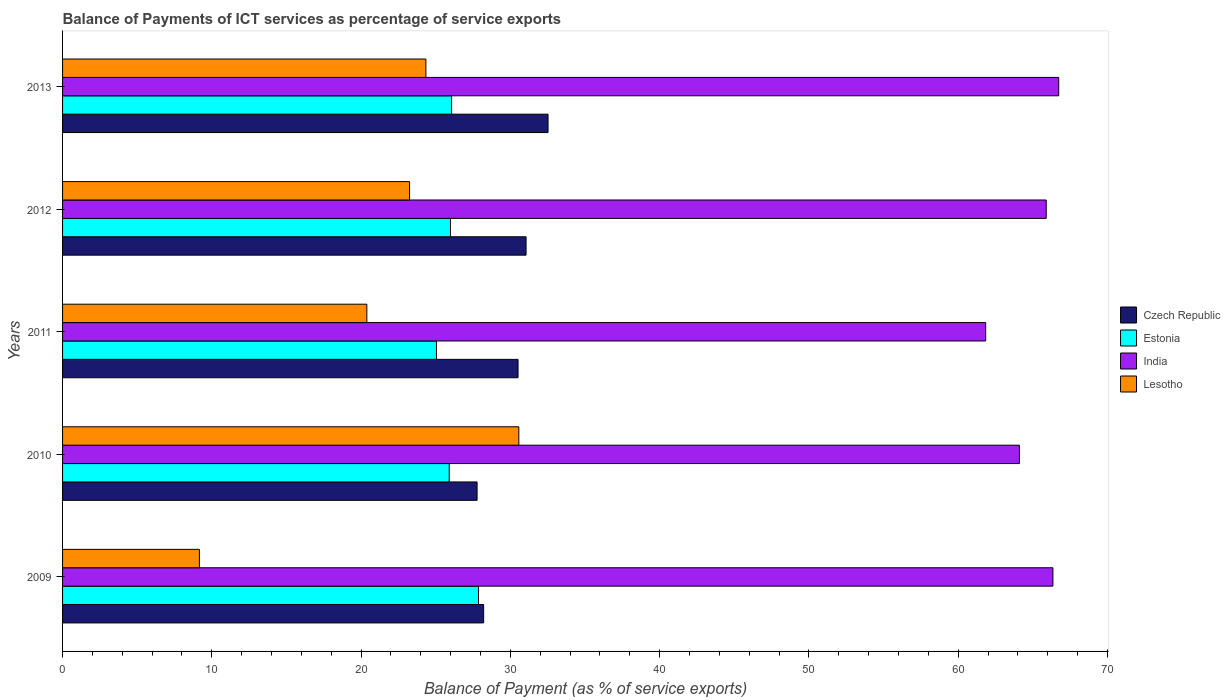How many different coloured bars are there?
Provide a short and direct response. 4. What is the label of the 1st group of bars from the top?
Offer a very short reply. 2013. In how many cases, is the number of bars for a given year not equal to the number of legend labels?
Offer a very short reply. 0. What is the balance of payments of ICT services in India in 2009?
Make the answer very short. 66.34. Across all years, what is the maximum balance of payments of ICT services in India?
Offer a very short reply. 66.73. Across all years, what is the minimum balance of payments of ICT services in India?
Keep it short and to the point. 61.84. In which year was the balance of payments of ICT services in Estonia minimum?
Ensure brevity in your answer.  2011. What is the total balance of payments of ICT services in Lesotho in the graph?
Provide a succinct answer. 107.7. What is the difference between the balance of payments of ICT services in India in 2010 and that in 2011?
Make the answer very short. 2.26. What is the difference between the balance of payments of ICT services in Estonia in 2009 and the balance of payments of ICT services in Lesotho in 2013?
Provide a succinct answer. 3.52. What is the average balance of payments of ICT services in India per year?
Keep it short and to the point. 64.98. In the year 2011, what is the difference between the balance of payments of ICT services in India and balance of payments of ICT services in Czech Republic?
Provide a succinct answer. 31.33. In how many years, is the balance of payments of ICT services in Lesotho greater than 26 %?
Provide a succinct answer. 1. What is the ratio of the balance of payments of ICT services in Lesotho in 2010 to that in 2012?
Your response must be concise. 1.31. Is the balance of payments of ICT services in India in 2011 less than that in 2012?
Keep it short and to the point. Yes. Is the difference between the balance of payments of ICT services in India in 2011 and 2012 greater than the difference between the balance of payments of ICT services in Czech Republic in 2011 and 2012?
Keep it short and to the point. No. What is the difference between the highest and the second highest balance of payments of ICT services in Estonia?
Ensure brevity in your answer.  1.8. What is the difference between the highest and the lowest balance of payments of ICT services in Lesotho?
Make the answer very short. 21.4. In how many years, is the balance of payments of ICT services in Estonia greater than the average balance of payments of ICT services in Estonia taken over all years?
Provide a succinct answer. 1. What does the 3rd bar from the top in 2013 represents?
Provide a succinct answer. Estonia. What does the 4th bar from the bottom in 2010 represents?
Provide a succinct answer. Lesotho. Is it the case that in every year, the sum of the balance of payments of ICT services in Czech Republic and balance of payments of ICT services in Lesotho is greater than the balance of payments of ICT services in Estonia?
Provide a short and direct response. Yes. How many bars are there?
Offer a terse response. 20. How many years are there in the graph?
Your answer should be very brief. 5. Are the values on the major ticks of X-axis written in scientific E-notation?
Your answer should be compact. No. Does the graph contain any zero values?
Ensure brevity in your answer.  No. Does the graph contain grids?
Offer a terse response. No. Where does the legend appear in the graph?
Provide a short and direct response. Center right. How many legend labels are there?
Keep it short and to the point. 4. What is the title of the graph?
Offer a very short reply. Balance of Payments of ICT services as percentage of service exports. Does "East Asia (all income levels)" appear as one of the legend labels in the graph?
Keep it short and to the point. No. What is the label or title of the X-axis?
Keep it short and to the point. Balance of Payment (as % of service exports). What is the label or title of the Y-axis?
Make the answer very short. Years. What is the Balance of Payment (as % of service exports) in Czech Republic in 2009?
Provide a succinct answer. 28.21. What is the Balance of Payment (as % of service exports) in Estonia in 2009?
Offer a very short reply. 27.86. What is the Balance of Payment (as % of service exports) in India in 2009?
Offer a terse response. 66.34. What is the Balance of Payment (as % of service exports) of Lesotho in 2009?
Keep it short and to the point. 9.17. What is the Balance of Payment (as % of service exports) in Czech Republic in 2010?
Ensure brevity in your answer.  27.77. What is the Balance of Payment (as % of service exports) in Estonia in 2010?
Keep it short and to the point. 25.9. What is the Balance of Payment (as % of service exports) of India in 2010?
Your answer should be compact. 64.1. What is the Balance of Payment (as % of service exports) of Lesotho in 2010?
Give a very brief answer. 30.56. What is the Balance of Payment (as % of service exports) of Czech Republic in 2011?
Ensure brevity in your answer.  30.51. What is the Balance of Payment (as % of service exports) of Estonia in 2011?
Offer a very short reply. 25.05. What is the Balance of Payment (as % of service exports) in India in 2011?
Ensure brevity in your answer.  61.84. What is the Balance of Payment (as % of service exports) in Lesotho in 2011?
Give a very brief answer. 20.38. What is the Balance of Payment (as % of service exports) of Czech Republic in 2012?
Offer a very short reply. 31.05. What is the Balance of Payment (as % of service exports) of Estonia in 2012?
Ensure brevity in your answer.  25.99. What is the Balance of Payment (as % of service exports) in India in 2012?
Provide a succinct answer. 65.89. What is the Balance of Payment (as % of service exports) in Lesotho in 2012?
Provide a short and direct response. 23.24. What is the Balance of Payment (as % of service exports) in Czech Republic in 2013?
Provide a short and direct response. 32.52. What is the Balance of Payment (as % of service exports) of Estonia in 2013?
Offer a terse response. 26.06. What is the Balance of Payment (as % of service exports) of India in 2013?
Ensure brevity in your answer.  66.73. What is the Balance of Payment (as % of service exports) in Lesotho in 2013?
Provide a short and direct response. 24.34. Across all years, what is the maximum Balance of Payment (as % of service exports) in Czech Republic?
Ensure brevity in your answer.  32.52. Across all years, what is the maximum Balance of Payment (as % of service exports) in Estonia?
Keep it short and to the point. 27.86. Across all years, what is the maximum Balance of Payment (as % of service exports) in India?
Provide a succinct answer. 66.73. Across all years, what is the maximum Balance of Payment (as % of service exports) of Lesotho?
Provide a succinct answer. 30.56. Across all years, what is the minimum Balance of Payment (as % of service exports) of Czech Republic?
Your answer should be very brief. 27.77. Across all years, what is the minimum Balance of Payment (as % of service exports) in Estonia?
Make the answer very short. 25.05. Across all years, what is the minimum Balance of Payment (as % of service exports) of India?
Your answer should be compact. 61.84. Across all years, what is the minimum Balance of Payment (as % of service exports) of Lesotho?
Keep it short and to the point. 9.17. What is the total Balance of Payment (as % of service exports) in Czech Republic in the graph?
Give a very brief answer. 150.06. What is the total Balance of Payment (as % of service exports) in Estonia in the graph?
Ensure brevity in your answer.  130.86. What is the total Balance of Payment (as % of service exports) in India in the graph?
Keep it short and to the point. 324.9. What is the total Balance of Payment (as % of service exports) of Lesotho in the graph?
Make the answer very short. 107.7. What is the difference between the Balance of Payment (as % of service exports) in Czech Republic in 2009 and that in 2010?
Offer a terse response. 0.44. What is the difference between the Balance of Payment (as % of service exports) in Estonia in 2009 and that in 2010?
Keep it short and to the point. 1.96. What is the difference between the Balance of Payment (as % of service exports) in India in 2009 and that in 2010?
Provide a short and direct response. 2.24. What is the difference between the Balance of Payment (as % of service exports) in Lesotho in 2009 and that in 2010?
Your response must be concise. -21.4. What is the difference between the Balance of Payment (as % of service exports) in Czech Republic in 2009 and that in 2011?
Offer a terse response. -2.3. What is the difference between the Balance of Payment (as % of service exports) in Estonia in 2009 and that in 2011?
Offer a very short reply. 2.82. What is the difference between the Balance of Payment (as % of service exports) of India in 2009 and that in 2011?
Provide a short and direct response. 4.5. What is the difference between the Balance of Payment (as % of service exports) of Lesotho in 2009 and that in 2011?
Make the answer very short. -11.22. What is the difference between the Balance of Payment (as % of service exports) of Czech Republic in 2009 and that in 2012?
Offer a very short reply. -2.84. What is the difference between the Balance of Payment (as % of service exports) in Estonia in 2009 and that in 2012?
Provide a short and direct response. 1.88. What is the difference between the Balance of Payment (as % of service exports) of India in 2009 and that in 2012?
Offer a terse response. 0.45. What is the difference between the Balance of Payment (as % of service exports) in Lesotho in 2009 and that in 2012?
Make the answer very short. -14.08. What is the difference between the Balance of Payment (as % of service exports) in Czech Republic in 2009 and that in 2013?
Keep it short and to the point. -4.31. What is the difference between the Balance of Payment (as % of service exports) of Estonia in 2009 and that in 2013?
Your answer should be very brief. 1.8. What is the difference between the Balance of Payment (as % of service exports) of India in 2009 and that in 2013?
Your answer should be compact. -0.39. What is the difference between the Balance of Payment (as % of service exports) in Lesotho in 2009 and that in 2013?
Give a very brief answer. -15.17. What is the difference between the Balance of Payment (as % of service exports) of Czech Republic in 2010 and that in 2011?
Offer a very short reply. -2.74. What is the difference between the Balance of Payment (as % of service exports) in Estonia in 2010 and that in 2011?
Offer a very short reply. 0.86. What is the difference between the Balance of Payment (as % of service exports) of India in 2010 and that in 2011?
Your response must be concise. 2.26. What is the difference between the Balance of Payment (as % of service exports) of Lesotho in 2010 and that in 2011?
Ensure brevity in your answer.  10.18. What is the difference between the Balance of Payment (as % of service exports) of Czech Republic in 2010 and that in 2012?
Keep it short and to the point. -3.28. What is the difference between the Balance of Payment (as % of service exports) in Estonia in 2010 and that in 2012?
Your answer should be very brief. -0.08. What is the difference between the Balance of Payment (as % of service exports) of India in 2010 and that in 2012?
Keep it short and to the point. -1.8. What is the difference between the Balance of Payment (as % of service exports) in Lesotho in 2010 and that in 2012?
Provide a succinct answer. 7.32. What is the difference between the Balance of Payment (as % of service exports) in Czech Republic in 2010 and that in 2013?
Provide a short and direct response. -4.75. What is the difference between the Balance of Payment (as % of service exports) of Estonia in 2010 and that in 2013?
Your response must be concise. -0.16. What is the difference between the Balance of Payment (as % of service exports) of India in 2010 and that in 2013?
Your answer should be very brief. -2.63. What is the difference between the Balance of Payment (as % of service exports) of Lesotho in 2010 and that in 2013?
Keep it short and to the point. 6.22. What is the difference between the Balance of Payment (as % of service exports) of Czech Republic in 2011 and that in 2012?
Provide a succinct answer. -0.54. What is the difference between the Balance of Payment (as % of service exports) of Estonia in 2011 and that in 2012?
Make the answer very short. -0.94. What is the difference between the Balance of Payment (as % of service exports) in India in 2011 and that in 2012?
Offer a very short reply. -4.06. What is the difference between the Balance of Payment (as % of service exports) in Lesotho in 2011 and that in 2012?
Your answer should be very brief. -2.86. What is the difference between the Balance of Payment (as % of service exports) in Czech Republic in 2011 and that in 2013?
Keep it short and to the point. -2.01. What is the difference between the Balance of Payment (as % of service exports) of Estonia in 2011 and that in 2013?
Offer a very short reply. -1.02. What is the difference between the Balance of Payment (as % of service exports) in India in 2011 and that in 2013?
Make the answer very short. -4.89. What is the difference between the Balance of Payment (as % of service exports) in Lesotho in 2011 and that in 2013?
Ensure brevity in your answer.  -3.96. What is the difference between the Balance of Payment (as % of service exports) in Czech Republic in 2012 and that in 2013?
Your answer should be compact. -1.47. What is the difference between the Balance of Payment (as % of service exports) of Estonia in 2012 and that in 2013?
Your answer should be very brief. -0.08. What is the difference between the Balance of Payment (as % of service exports) in India in 2012 and that in 2013?
Your answer should be compact. -0.84. What is the difference between the Balance of Payment (as % of service exports) in Lesotho in 2012 and that in 2013?
Provide a short and direct response. -1.1. What is the difference between the Balance of Payment (as % of service exports) of Czech Republic in 2009 and the Balance of Payment (as % of service exports) of Estonia in 2010?
Your response must be concise. 2.31. What is the difference between the Balance of Payment (as % of service exports) in Czech Republic in 2009 and the Balance of Payment (as % of service exports) in India in 2010?
Your answer should be very brief. -35.89. What is the difference between the Balance of Payment (as % of service exports) in Czech Republic in 2009 and the Balance of Payment (as % of service exports) in Lesotho in 2010?
Keep it short and to the point. -2.36. What is the difference between the Balance of Payment (as % of service exports) in Estonia in 2009 and the Balance of Payment (as % of service exports) in India in 2010?
Offer a terse response. -36.24. What is the difference between the Balance of Payment (as % of service exports) of Estonia in 2009 and the Balance of Payment (as % of service exports) of Lesotho in 2010?
Offer a terse response. -2.7. What is the difference between the Balance of Payment (as % of service exports) of India in 2009 and the Balance of Payment (as % of service exports) of Lesotho in 2010?
Provide a short and direct response. 35.78. What is the difference between the Balance of Payment (as % of service exports) in Czech Republic in 2009 and the Balance of Payment (as % of service exports) in Estonia in 2011?
Make the answer very short. 3.16. What is the difference between the Balance of Payment (as % of service exports) of Czech Republic in 2009 and the Balance of Payment (as % of service exports) of India in 2011?
Your answer should be compact. -33.63. What is the difference between the Balance of Payment (as % of service exports) of Czech Republic in 2009 and the Balance of Payment (as % of service exports) of Lesotho in 2011?
Provide a succinct answer. 7.82. What is the difference between the Balance of Payment (as % of service exports) in Estonia in 2009 and the Balance of Payment (as % of service exports) in India in 2011?
Your answer should be compact. -33.98. What is the difference between the Balance of Payment (as % of service exports) of Estonia in 2009 and the Balance of Payment (as % of service exports) of Lesotho in 2011?
Offer a terse response. 7.48. What is the difference between the Balance of Payment (as % of service exports) in India in 2009 and the Balance of Payment (as % of service exports) in Lesotho in 2011?
Keep it short and to the point. 45.96. What is the difference between the Balance of Payment (as % of service exports) in Czech Republic in 2009 and the Balance of Payment (as % of service exports) in Estonia in 2012?
Make the answer very short. 2.22. What is the difference between the Balance of Payment (as % of service exports) in Czech Republic in 2009 and the Balance of Payment (as % of service exports) in India in 2012?
Ensure brevity in your answer.  -37.69. What is the difference between the Balance of Payment (as % of service exports) of Czech Republic in 2009 and the Balance of Payment (as % of service exports) of Lesotho in 2012?
Make the answer very short. 4.96. What is the difference between the Balance of Payment (as % of service exports) of Estonia in 2009 and the Balance of Payment (as % of service exports) of India in 2012?
Provide a short and direct response. -38.03. What is the difference between the Balance of Payment (as % of service exports) of Estonia in 2009 and the Balance of Payment (as % of service exports) of Lesotho in 2012?
Offer a very short reply. 4.62. What is the difference between the Balance of Payment (as % of service exports) in India in 2009 and the Balance of Payment (as % of service exports) in Lesotho in 2012?
Give a very brief answer. 43.1. What is the difference between the Balance of Payment (as % of service exports) in Czech Republic in 2009 and the Balance of Payment (as % of service exports) in Estonia in 2013?
Offer a very short reply. 2.15. What is the difference between the Balance of Payment (as % of service exports) of Czech Republic in 2009 and the Balance of Payment (as % of service exports) of India in 2013?
Ensure brevity in your answer.  -38.52. What is the difference between the Balance of Payment (as % of service exports) of Czech Republic in 2009 and the Balance of Payment (as % of service exports) of Lesotho in 2013?
Offer a very short reply. 3.87. What is the difference between the Balance of Payment (as % of service exports) of Estonia in 2009 and the Balance of Payment (as % of service exports) of India in 2013?
Ensure brevity in your answer.  -38.87. What is the difference between the Balance of Payment (as % of service exports) of Estonia in 2009 and the Balance of Payment (as % of service exports) of Lesotho in 2013?
Make the answer very short. 3.52. What is the difference between the Balance of Payment (as % of service exports) of India in 2009 and the Balance of Payment (as % of service exports) of Lesotho in 2013?
Provide a short and direct response. 42. What is the difference between the Balance of Payment (as % of service exports) in Czech Republic in 2010 and the Balance of Payment (as % of service exports) in Estonia in 2011?
Your answer should be very brief. 2.72. What is the difference between the Balance of Payment (as % of service exports) of Czech Republic in 2010 and the Balance of Payment (as % of service exports) of India in 2011?
Ensure brevity in your answer.  -34.07. What is the difference between the Balance of Payment (as % of service exports) of Czech Republic in 2010 and the Balance of Payment (as % of service exports) of Lesotho in 2011?
Your response must be concise. 7.38. What is the difference between the Balance of Payment (as % of service exports) of Estonia in 2010 and the Balance of Payment (as % of service exports) of India in 2011?
Give a very brief answer. -35.94. What is the difference between the Balance of Payment (as % of service exports) in Estonia in 2010 and the Balance of Payment (as % of service exports) in Lesotho in 2011?
Your answer should be very brief. 5.52. What is the difference between the Balance of Payment (as % of service exports) in India in 2010 and the Balance of Payment (as % of service exports) in Lesotho in 2011?
Your answer should be compact. 43.71. What is the difference between the Balance of Payment (as % of service exports) of Czech Republic in 2010 and the Balance of Payment (as % of service exports) of Estonia in 2012?
Ensure brevity in your answer.  1.78. What is the difference between the Balance of Payment (as % of service exports) in Czech Republic in 2010 and the Balance of Payment (as % of service exports) in India in 2012?
Your answer should be compact. -38.13. What is the difference between the Balance of Payment (as % of service exports) in Czech Republic in 2010 and the Balance of Payment (as % of service exports) in Lesotho in 2012?
Ensure brevity in your answer.  4.52. What is the difference between the Balance of Payment (as % of service exports) in Estonia in 2010 and the Balance of Payment (as % of service exports) in India in 2012?
Provide a succinct answer. -39.99. What is the difference between the Balance of Payment (as % of service exports) in Estonia in 2010 and the Balance of Payment (as % of service exports) in Lesotho in 2012?
Provide a succinct answer. 2.66. What is the difference between the Balance of Payment (as % of service exports) of India in 2010 and the Balance of Payment (as % of service exports) of Lesotho in 2012?
Your answer should be very brief. 40.85. What is the difference between the Balance of Payment (as % of service exports) in Czech Republic in 2010 and the Balance of Payment (as % of service exports) in Estonia in 2013?
Provide a short and direct response. 1.71. What is the difference between the Balance of Payment (as % of service exports) of Czech Republic in 2010 and the Balance of Payment (as % of service exports) of India in 2013?
Provide a short and direct response. -38.96. What is the difference between the Balance of Payment (as % of service exports) in Czech Republic in 2010 and the Balance of Payment (as % of service exports) in Lesotho in 2013?
Ensure brevity in your answer.  3.43. What is the difference between the Balance of Payment (as % of service exports) of Estonia in 2010 and the Balance of Payment (as % of service exports) of India in 2013?
Give a very brief answer. -40.83. What is the difference between the Balance of Payment (as % of service exports) in Estonia in 2010 and the Balance of Payment (as % of service exports) in Lesotho in 2013?
Provide a short and direct response. 1.56. What is the difference between the Balance of Payment (as % of service exports) in India in 2010 and the Balance of Payment (as % of service exports) in Lesotho in 2013?
Ensure brevity in your answer.  39.76. What is the difference between the Balance of Payment (as % of service exports) in Czech Republic in 2011 and the Balance of Payment (as % of service exports) in Estonia in 2012?
Your answer should be compact. 4.53. What is the difference between the Balance of Payment (as % of service exports) of Czech Republic in 2011 and the Balance of Payment (as % of service exports) of India in 2012?
Ensure brevity in your answer.  -35.38. What is the difference between the Balance of Payment (as % of service exports) in Czech Republic in 2011 and the Balance of Payment (as % of service exports) in Lesotho in 2012?
Make the answer very short. 7.27. What is the difference between the Balance of Payment (as % of service exports) of Estonia in 2011 and the Balance of Payment (as % of service exports) of India in 2012?
Offer a very short reply. -40.85. What is the difference between the Balance of Payment (as % of service exports) in Estonia in 2011 and the Balance of Payment (as % of service exports) in Lesotho in 2012?
Your response must be concise. 1.8. What is the difference between the Balance of Payment (as % of service exports) in India in 2011 and the Balance of Payment (as % of service exports) in Lesotho in 2012?
Provide a succinct answer. 38.59. What is the difference between the Balance of Payment (as % of service exports) of Czech Republic in 2011 and the Balance of Payment (as % of service exports) of Estonia in 2013?
Offer a terse response. 4.45. What is the difference between the Balance of Payment (as % of service exports) of Czech Republic in 2011 and the Balance of Payment (as % of service exports) of India in 2013?
Provide a short and direct response. -36.22. What is the difference between the Balance of Payment (as % of service exports) in Czech Republic in 2011 and the Balance of Payment (as % of service exports) in Lesotho in 2013?
Keep it short and to the point. 6.17. What is the difference between the Balance of Payment (as % of service exports) in Estonia in 2011 and the Balance of Payment (as % of service exports) in India in 2013?
Your answer should be very brief. -41.68. What is the difference between the Balance of Payment (as % of service exports) in Estonia in 2011 and the Balance of Payment (as % of service exports) in Lesotho in 2013?
Your answer should be compact. 0.71. What is the difference between the Balance of Payment (as % of service exports) of India in 2011 and the Balance of Payment (as % of service exports) of Lesotho in 2013?
Your answer should be compact. 37.5. What is the difference between the Balance of Payment (as % of service exports) of Czech Republic in 2012 and the Balance of Payment (as % of service exports) of Estonia in 2013?
Offer a very short reply. 4.99. What is the difference between the Balance of Payment (as % of service exports) of Czech Republic in 2012 and the Balance of Payment (as % of service exports) of India in 2013?
Provide a short and direct response. -35.68. What is the difference between the Balance of Payment (as % of service exports) of Czech Republic in 2012 and the Balance of Payment (as % of service exports) of Lesotho in 2013?
Your response must be concise. 6.71. What is the difference between the Balance of Payment (as % of service exports) of Estonia in 2012 and the Balance of Payment (as % of service exports) of India in 2013?
Give a very brief answer. -40.74. What is the difference between the Balance of Payment (as % of service exports) of Estonia in 2012 and the Balance of Payment (as % of service exports) of Lesotho in 2013?
Make the answer very short. 1.65. What is the difference between the Balance of Payment (as % of service exports) in India in 2012 and the Balance of Payment (as % of service exports) in Lesotho in 2013?
Offer a very short reply. 41.55. What is the average Balance of Payment (as % of service exports) in Czech Republic per year?
Your answer should be very brief. 30.01. What is the average Balance of Payment (as % of service exports) of Estonia per year?
Offer a very short reply. 26.17. What is the average Balance of Payment (as % of service exports) of India per year?
Offer a terse response. 64.98. What is the average Balance of Payment (as % of service exports) in Lesotho per year?
Your answer should be very brief. 21.54. In the year 2009, what is the difference between the Balance of Payment (as % of service exports) in Czech Republic and Balance of Payment (as % of service exports) in Estonia?
Keep it short and to the point. 0.35. In the year 2009, what is the difference between the Balance of Payment (as % of service exports) in Czech Republic and Balance of Payment (as % of service exports) in India?
Your answer should be very brief. -38.13. In the year 2009, what is the difference between the Balance of Payment (as % of service exports) in Czech Republic and Balance of Payment (as % of service exports) in Lesotho?
Your answer should be very brief. 19.04. In the year 2009, what is the difference between the Balance of Payment (as % of service exports) in Estonia and Balance of Payment (as % of service exports) in India?
Your answer should be very brief. -38.48. In the year 2009, what is the difference between the Balance of Payment (as % of service exports) in Estonia and Balance of Payment (as % of service exports) in Lesotho?
Provide a short and direct response. 18.7. In the year 2009, what is the difference between the Balance of Payment (as % of service exports) in India and Balance of Payment (as % of service exports) in Lesotho?
Your answer should be very brief. 57.18. In the year 2010, what is the difference between the Balance of Payment (as % of service exports) of Czech Republic and Balance of Payment (as % of service exports) of Estonia?
Provide a short and direct response. 1.87. In the year 2010, what is the difference between the Balance of Payment (as % of service exports) in Czech Republic and Balance of Payment (as % of service exports) in India?
Provide a succinct answer. -36.33. In the year 2010, what is the difference between the Balance of Payment (as % of service exports) of Czech Republic and Balance of Payment (as % of service exports) of Lesotho?
Provide a succinct answer. -2.8. In the year 2010, what is the difference between the Balance of Payment (as % of service exports) of Estonia and Balance of Payment (as % of service exports) of India?
Provide a succinct answer. -38.2. In the year 2010, what is the difference between the Balance of Payment (as % of service exports) in Estonia and Balance of Payment (as % of service exports) in Lesotho?
Make the answer very short. -4.66. In the year 2010, what is the difference between the Balance of Payment (as % of service exports) of India and Balance of Payment (as % of service exports) of Lesotho?
Make the answer very short. 33.53. In the year 2011, what is the difference between the Balance of Payment (as % of service exports) of Czech Republic and Balance of Payment (as % of service exports) of Estonia?
Provide a succinct answer. 5.46. In the year 2011, what is the difference between the Balance of Payment (as % of service exports) of Czech Republic and Balance of Payment (as % of service exports) of India?
Ensure brevity in your answer.  -31.33. In the year 2011, what is the difference between the Balance of Payment (as % of service exports) of Czech Republic and Balance of Payment (as % of service exports) of Lesotho?
Give a very brief answer. 10.13. In the year 2011, what is the difference between the Balance of Payment (as % of service exports) of Estonia and Balance of Payment (as % of service exports) of India?
Keep it short and to the point. -36.79. In the year 2011, what is the difference between the Balance of Payment (as % of service exports) in Estonia and Balance of Payment (as % of service exports) in Lesotho?
Provide a short and direct response. 4.66. In the year 2011, what is the difference between the Balance of Payment (as % of service exports) of India and Balance of Payment (as % of service exports) of Lesotho?
Give a very brief answer. 41.45. In the year 2012, what is the difference between the Balance of Payment (as % of service exports) in Czech Republic and Balance of Payment (as % of service exports) in Estonia?
Your response must be concise. 5.06. In the year 2012, what is the difference between the Balance of Payment (as % of service exports) in Czech Republic and Balance of Payment (as % of service exports) in India?
Ensure brevity in your answer.  -34.85. In the year 2012, what is the difference between the Balance of Payment (as % of service exports) in Czech Republic and Balance of Payment (as % of service exports) in Lesotho?
Make the answer very short. 7.8. In the year 2012, what is the difference between the Balance of Payment (as % of service exports) in Estonia and Balance of Payment (as % of service exports) in India?
Make the answer very short. -39.91. In the year 2012, what is the difference between the Balance of Payment (as % of service exports) of Estonia and Balance of Payment (as % of service exports) of Lesotho?
Your answer should be compact. 2.74. In the year 2012, what is the difference between the Balance of Payment (as % of service exports) of India and Balance of Payment (as % of service exports) of Lesotho?
Your answer should be compact. 42.65. In the year 2013, what is the difference between the Balance of Payment (as % of service exports) of Czech Republic and Balance of Payment (as % of service exports) of Estonia?
Keep it short and to the point. 6.46. In the year 2013, what is the difference between the Balance of Payment (as % of service exports) in Czech Republic and Balance of Payment (as % of service exports) in India?
Your response must be concise. -34.21. In the year 2013, what is the difference between the Balance of Payment (as % of service exports) in Czech Republic and Balance of Payment (as % of service exports) in Lesotho?
Offer a very short reply. 8.18. In the year 2013, what is the difference between the Balance of Payment (as % of service exports) of Estonia and Balance of Payment (as % of service exports) of India?
Give a very brief answer. -40.67. In the year 2013, what is the difference between the Balance of Payment (as % of service exports) of Estonia and Balance of Payment (as % of service exports) of Lesotho?
Make the answer very short. 1.72. In the year 2013, what is the difference between the Balance of Payment (as % of service exports) in India and Balance of Payment (as % of service exports) in Lesotho?
Provide a short and direct response. 42.39. What is the ratio of the Balance of Payment (as % of service exports) of Czech Republic in 2009 to that in 2010?
Your response must be concise. 1.02. What is the ratio of the Balance of Payment (as % of service exports) of Estonia in 2009 to that in 2010?
Make the answer very short. 1.08. What is the ratio of the Balance of Payment (as % of service exports) of India in 2009 to that in 2010?
Ensure brevity in your answer.  1.03. What is the ratio of the Balance of Payment (as % of service exports) of Lesotho in 2009 to that in 2010?
Keep it short and to the point. 0.3. What is the ratio of the Balance of Payment (as % of service exports) in Czech Republic in 2009 to that in 2011?
Keep it short and to the point. 0.92. What is the ratio of the Balance of Payment (as % of service exports) of Estonia in 2009 to that in 2011?
Ensure brevity in your answer.  1.11. What is the ratio of the Balance of Payment (as % of service exports) in India in 2009 to that in 2011?
Your response must be concise. 1.07. What is the ratio of the Balance of Payment (as % of service exports) in Lesotho in 2009 to that in 2011?
Your answer should be compact. 0.45. What is the ratio of the Balance of Payment (as % of service exports) in Czech Republic in 2009 to that in 2012?
Provide a succinct answer. 0.91. What is the ratio of the Balance of Payment (as % of service exports) in Estonia in 2009 to that in 2012?
Offer a very short reply. 1.07. What is the ratio of the Balance of Payment (as % of service exports) of India in 2009 to that in 2012?
Ensure brevity in your answer.  1.01. What is the ratio of the Balance of Payment (as % of service exports) in Lesotho in 2009 to that in 2012?
Offer a very short reply. 0.39. What is the ratio of the Balance of Payment (as % of service exports) of Czech Republic in 2009 to that in 2013?
Your response must be concise. 0.87. What is the ratio of the Balance of Payment (as % of service exports) of Estonia in 2009 to that in 2013?
Your response must be concise. 1.07. What is the ratio of the Balance of Payment (as % of service exports) in Lesotho in 2009 to that in 2013?
Your answer should be very brief. 0.38. What is the ratio of the Balance of Payment (as % of service exports) in Czech Republic in 2010 to that in 2011?
Keep it short and to the point. 0.91. What is the ratio of the Balance of Payment (as % of service exports) in Estonia in 2010 to that in 2011?
Your answer should be very brief. 1.03. What is the ratio of the Balance of Payment (as % of service exports) of India in 2010 to that in 2011?
Offer a very short reply. 1.04. What is the ratio of the Balance of Payment (as % of service exports) in Lesotho in 2010 to that in 2011?
Give a very brief answer. 1.5. What is the ratio of the Balance of Payment (as % of service exports) in Czech Republic in 2010 to that in 2012?
Make the answer very short. 0.89. What is the ratio of the Balance of Payment (as % of service exports) of India in 2010 to that in 2012?
Provide a succinct answer. 0.97. What is the ratio of the Balance of Payment (as % of service exports) of Lesotho in 2010 to that in 2012?
Your answer should be very brief. 1.31. What is the ratio of the Balance of Payment (as % of service exports) in Czech Republic in 2010 to that in 2013?
Your answer should be compact. 0.85. What is the ratio of the Balance of Payment (as % of service exports) in India in 2010 to that in 2013?
Ensure brevity in your answer.  0.96. What is the ratio of the Balance of Payment (as % of service exports) of Lesotho in 2010 to that in 2013?
Your response must be concise. 1.26. What is the ratio of the Balance of Payment (as % of service exports) in Czech Republic in 2011 to that in 2012?
Make the answer very short. 0.98. What is the ratio of the Balance of Payment (as % of service exports) of Estonia in 2011 to that in 2012?
Provide a short and direct response. 0.96. What is the ratio of the Balance of Payment (as % of service exports) in India in 2011 to that in 2012?
Provide a short and direct response. 0.94. What is the ratio of the Balance of Payment (as % of service exports) of Lesotho in 2011 to that in 2012?
Provide a succinct answer. 0.88. What is the ratio of the Balance of Payment (as % of service exports) in Czech Republic in 2011 to that in 2013?
Provide a short and direct response. 0.94. What is the ratio of the Balance of Payment (as % of service exports) in Estonia in 2011 to that in 2013?
Make the answer very short. 0.96. What is the ratio of the Balance of Payment (as % of service exports) in India in 2011 to that in 2013?
Give a very brief answer. 0.93. What is the ratio of the Balance of Payment (as % of service exports) of Lesotho in 2011 to that in 2013?
Ensure brevity in your answer.  0.84. What is the ratio of the Balance of Payment (as % of service exports) of Czech Republic in 2012 to that in 2013?
Keep it short and to the point. 0.95. What is the ratio of the Balance of Payment (as % of service exports) of India in 2012 to that in 2013?
Keep it short and to the point. 0.99. What is the ratio of the Balance of Payment (as % of service exports) in Lesotho in 2012 to that in 2013?
Offer a terse response. 0.95. What is the difference between the highest and the second highest Balance of Payment (as % of service exports) of Czech Republic?
Provide a short and direct response. 1.47. What is the difference between the highest and the second highest Balance of Payment (as % of service exports) in Estonia?
Ensure brevity in your answer.  1.8. What is the difference between the highest and the second highest Balance of Payment (as % of service exports) of India?
Your response must be concise. 0.39. What is the difference between the highest and the second highest Balance of Payment (as % of service exports) of Lesotho?
Offer a very short reply. 6.22. What is the difference between the highest and the lowest Balance of Payment (as % of service exports) in Czech Republic?
Provide a succinct answer. 4.75. What is the difference between the highest and the lowest Balance of Payment (as % of service exports) in Estonia?
Your answer should be very brief. 2.82. What is the difference between the highest and the lowest Balance of Payment (as % of service exports) in India?
Offer a very short reply. 4.89. What is the difference between the highest and the lowest Balance of Payment (as % of service exports) of Lesotho?
Provide a short and direct response. 21.4. 